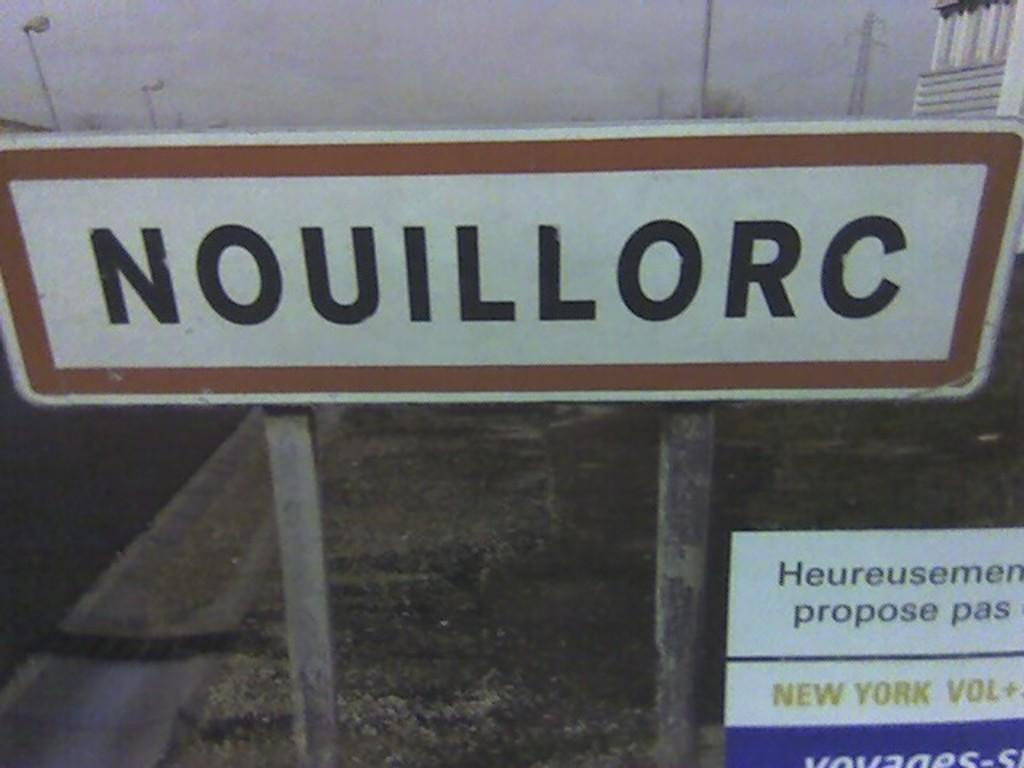Provide a one-sentence caption for the provided image. street sign that reads nouillorc looks to be from over seas. 